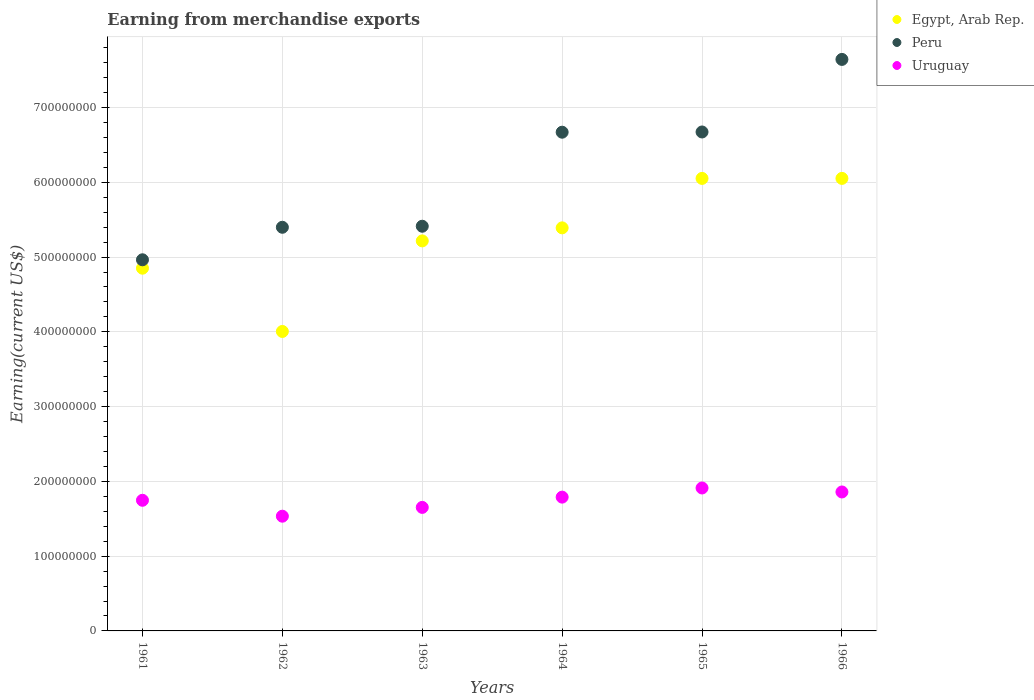What is the amount earned from merchandise exports in Peru in 1964?
Your answer should be compact. 6.67e+08. Across all years, what is the maximum amount earned from merchandise exports in Egypt, Arab Rep.?
Your response must be concise. 6.05e+08. Across all years, what is the minimum amount earned from merchandise exports in Uruguay?
Ensure brevity in your answer.  1.53e+08. In which year was the amount earned from merchandise exports in Uruguay maximum?
Keep it short and to the point. 1965. In which year was the amount earned from merchandise exports in Egypt, Arab Rep. minimum?
Offer a very short reply. 1962. What is the total amount earned from merchandise exports in Egypt, Arab Rep. in the graph?
Your answer should be compact. 3.16e+09. What is the difference between the amount earned from merchandise exports in Peru in 1961 and that in 1962?
Ensure brevity in your answer.  -4.35e+07. What is the difference between the amount earned from merchandise exports in Uruguay in 1962 and the amount earned from merchandise exports in Egypt, Arab Rep. in 1961?
Your response must be concise. -3.32e+08. What is the average amount earned from merchandise exports in Uruguay per year?
Provide a short and direct response. 1.75e+08. In the year 1962, what is the difference between the amount earned from merchandise exports in Uruguay and amount earned from merchandise exports in Peru?
Your answer should be compact. -3.86e+08. In how many years, is the amount earned from merchandise exports in Egypt, Arab Rep. greater than 540000000 US$?
Your response must be concise. 2. What is the ratio of the amount earned from merchandise exports in Egypt, Arab Rep. in 1962 to that in 1966?
Give a very brief answer. 0.66. What is the difference between the highest and the second highest amount earned from merchandise exports in Egypt, Arab Rep.?
Offer a very short reply. 2.30e+04. What is the difference between the highest and the lowest amount earned from merchandise exports in Peru?
Offer a terse response. 2.68e+08. In how many years, is the amount earned from merchandise exports in Peru greater than the average amount earned from merchandise exports in Peru taken over all years?
Give a very brief answer. 3. Is the sum of the amount earned from merchandise exports in Egypt, Arab Rep. in 1962 and 1965 greater than the maximum amount earned from merchandise exports in Peru across all years?
Ensure brevity in your answer.  Yes. Is it the case that in every year, the sum of the amount earned from merchandise exports in Peru and amount earned from merchandise exports in Egypt, Arab Rep.  is greater than the amount earned from merchandise exports in Uruguay?
Offer a terse response. Yes. Does the amount earned from merchandise exports in Peru monotonically increase over the years?
Ensure brevity in your answer.  Yes. How many dotlines are there?
Make the answer very short. 3. How many years are there in the graph?
Ensure brevity in your answer.  6. Are the values on the major ticks of Y-axis written in scientific E-notation?
Give a very brief answer. No. Does the graph contain any zero values?
Provide a short and direct response. No. Does the graph contain grids?
Make the answer very short. Yes. What is the title of the graph?
Offer a very short reply. Earning from merchandise exports. Does "Gabon" appear as one of the legend labels in the graph?
Your response must be concise. No. What is the label or title of the Y-axis?
Provide a short and direct response. Earning(current US$). What is the Earning(current US$) in Egypt, Arab Rep. in 1961?
Your response must be concise. 4.85e+08. What is the Earning(current US$) of Peru in 1961?
Provide a succinct answer. 4.96e+08. What is the Earning(current US$) in Uruguay in 1961?
Offer a terse response. 1.75e+08. What is the Earning(current US$) of Egypt, Arab Rep. in 1962?
Offer a very short reply. 4.01e+08. What is the Earning(current US$) of Peru in 1962?
Offer a terse response. 5.40e+08. What is the Earning(current US$) of Uruguay in 1962?
Provide a succinct answer. 1.53e+08. What is the Earning(current US$) in Egypt, Arab Rep. in 1963?
Provide a succinct answer. 5.22e+08. What is the Earning(current US$) of Peru in 1963?
Your answer should be compact. 5.41e+08. What is the Earning(current US$) of Uruguay in 1963?
Your answer should be very brief. 1.65e+08. What is the Earning(current US$) of Egypt, Arab Rep. in 1964?
Provide a short and direct response. 5.39e+08. What is the Earning(current US$) in Peru in 1964?
Provide a short and direct response. 6.67e+08. What is the Earning(current US$) in Uruguay in 1964?
Offer a terse response. 1.79e+08. What is the Earning(current US$) in Egypt, Arab Rep. in 1965?
Provide a succinct answer. 6.05e+08. What is the Earning(current US$) of Peru in 1965?
Ensure brevity in your answer.  6.67e+08. What is the Earning(current US$) in Uruguay in 1965?
Keep it short and to the point. 1.91e+08. What is the Earning(current US$) in Egypt, Arab Rep. in 1966?
Offer a very short reply. 6.05e+08. What is the Earning(current US$) of Peru in 1966?
Your answer should be very brief. 7.64e+08. What is the Earning(current US$) in Uruguay in 1966?
Your response must be concise. 1.86e+08. Across all years, what is the maximum Earning(current US$) of Egypt, Arab Rep.?
Keep it short and to the point. 6.05e+08. Across all years, what is the maximum Earning(current US$) of Peru?
Keep it short and to the point. 7.64e+08. Across all years, what is the maximum Earning(current US$) of Uruguay?
Your answer should be compact. 1.91e+08. Across all years, what is the minimum Earning(current US$) in Egypt, Arab Rep.?
Keep it short and to the point. 4.01e+08. Across all years, what is the minimum Earning(current US$) in Peru?
Your answer should be compact. 4.96e+08. Across all years, what is the minimum Earning(current US$) of Uruguay?
Make the answer very short. 1.53e+08. What is the total Earning(current US$) in Egypt, Arab Rep. in the graph?
Keep it short and to the point. 3.16e+09. What is the total Earning(current US$) in Peru in the graph?
Offer a very short reply. 3.68e+09. What is the total Earning(current US$) in Uruguay in the graph?
Your answer should be very brief. 1.05e+09. What is the difference between the Earning(current US$) in Egypt, Arab Rep. in 1961 and that in 1962?
Keep it short and to the point. 8.46e+07. What is the difference between the Earning(current US$) in Peru in 1961 and that in 1962?
Give a very brief answer. -4.35e+07. What is the difference between the Earning(current US$) in Uruguay in 1961 and that in 1962?
Offer a terse response. 2.13e+07. What is the difference between the Earning(current US$) in Egypt, Arab Rep. in 1961 and that in 1963?
Provide a succinct answer. -3.65e+07. What is the difference between the Earning(current US$) in Peru in 1961 and that in 1963?
Ensure brevity in your answer.  -4.49e+07. What is the difference between the Earning(current US$) of Uruguay in 1961 and that in 1963?
Provide a succinct answer. 9.51e+06. What is the difference between the Earning(current US$) in Egypt, Arab Rep. in 1961 and that in 1964?
Make the answer very short. -5.40e+07. What is the difference between the Earning(current US$) in Peru in 1961 and that in 1964?
Provide a succinct answer. -1.71e+08. What is the difference between the Earning(current US$) of Uruguay in 1961 and that in 1964?
Keep it short and to the point. -4.22e+06. What is the difference between the Earning(current US$) of Egypt, Arab Rep. in 1961 and that in 1965?
Offer a terse response. -1.20e+08. What is the difference between the Earning(current US$) of Peru in 1961 and that in 1965?
Make the answer very short. -1.71e+08. What is the difference between the Earning(current US$) in Uruguay in 1961 and that in 1965?
Provide a short and direct response. -1.64e+07. What is the difference between the Earning(current US$) in Egypt, Arab Rep. in 1961 and that in 1966?
Give a very brief answer. -1.20e+08. What is the difference between the Earning(current US$) of Peru in 1961 and that in 1966?
Your response must be concise. -2.68e+08. What is the difference between the Earning(current US$) in Uruguay in 1961 and that in 1966?
Give a very brief answer. -1.11e+07. What is the difference between the Earning(current US$) in Egypt, Arab Rep. in 1962 and that in 1963?
Provide a short and direct response. -1.21e+08. What is the difference between the Earning(current US$) of Peru in 1962 and that in 1963?
Your answer should be very brief. -1.38e+06. What is the difference between the Earning(current US$) in Uruguay in 1962 and that in 1963?
Give a very brief answer. -1.18e+07. What is the difference between the Earning(current US$) in Egypt, Arab Rep. in 1962 and that in 1964?
Make the answer very short. -1.39e+08. What is the difference between the Earning(current US$) in Peru in 1962 and that in 1964?
Provide a short and direct response. -1.27e+08. What is the difference between the Earning(current US$) in Uruguay in 1962 and that in 1964?
Offer a very short reply. -2.55e+07. What is the difference between the Earning(current US$) of Egypt, Arab Rep. in 1962 and that in 1965?
Your response must be concise. -2.05e+08. What is the difference between the Earning(current US$) in Peru in 1962 and that in 1965?
Your response must be concise. -1.27e+08. What is the difference between the Earning(current US$) in Uruguay in 1962 and that in 1965?
Your response must be concise. -3.77e+07. What is the difference between the Earning(current US$) in Egypt, Arab Rep. in 1962 and that in 1966?
Your response must be concise. -2.05e+08. What is the difference between the Earning(current US$) in Peru in 1962 and that in 1966?
Provide a short and direct response. -2.25e+08. What is the difference between the Earning(current US$) of Uruguay in 1962 and that in 1966?
Keep it short and to the point. -3.24e+07. What is the difference between the Earning(current US$) in Egypt, Arab Rep. in 1963 and that in 1964?
Your answer should be very brief. -1.74e+07. What is the difference between the Earning(current US$) in Peru in 1963 and that in 1964?
Provide a short and direct response. -1.26e+08. What is the difference between the Earning(current US$) of Uruguay in 1963 and that in 1964?
Ensure brevity in your answer.  -1.37e+07. What is the difference between the Earning(current US$) of Egypt, Arab Rep. in 1963 and that in 1965?
Offer a terse response. -8.36e+07. What is the difference between the Earning(current US$) of Peru in 1963 and that in 1965?
Your answer should be compact. -1.26e+08. What is the difference between the Earning(current US$) in Uruguay in 1963 and that in 1965?
Keep it short and to the point. -2.60e+07. What is the difference between the Earning(current US$) of Egypt, Arab Rep. in 1963 and that in 1966?
Keep it short and to the point. -8.36e+07. What is the difference between the Earning(current US$) of Peru in 1963 and that in 1966?
Provide a succinct answer. -2.23e+08. What is the difference between the Earning(current US$) in Uruguay in 1963 and that in 1966?
Offer a terse response. -2.06e+07. What is the difference between the Earning(current US$) of Egypt, Arab Rep. in 1964 and that in 1965?
Ensure brevity in your answer.  -6.61e+07. What is the difference between the Earning(current US$) of Peru in 1964 and that in 1965?
Your answer should be very brief. -2.99e+05. What is the difference between the Earning(current US$) in Uruguay in 1964 and that in 1965?
Provide a short and direct response. -1.22e+07. What is the difference between the Earning(current US$) of Egypt, Arab Rep. in 1964 and that in 1966?
Make the answer very short. -6.61e+07. What is the difference between the Earning(current US$) in Peru in 1964 and that in 1966?
Ensure brevity in your answer.  -9.74e+07. What is the difference between the Earning(current US$) of Uruguay in 1964 and that in 1966?
Ensure brevity in your answer.  -6.90e+06. What is the difference between the Earning(current US$) in Egypt, Arab Rep. in 1965 and that in 1966?
Your answer should be very brief. -2.30e+04. What is the difference between the Earning(current US$) of Peru in 1965 and that in 1966?
Your response must be concise. -9.71e+07. What is the difference between the Earning(current US$) in Uruguay in 1965 and that in 1966?
Your response must be concise. 5.33e+06. What is the difference between the Earning(current US$) in Egypt, Arab Rep. in 1961 and the Earning(current US$) in Peru in 1962?
Offer a very short reply. -5.47e+07. What is the difference between the Earning(current US$) in Egypt, Arab Rep. in 1961 and the Earning(current US$) in Uruguay in 1962?
Offer a terse response. 3.32e+08. What is the difference between the Earning(current US$) in Peru in 1961 and the Earning(current US$) in Uruguay in 1962?
Your response must be concise. 3.43e+08. What is the difference between the Earning(current US$) of Egypt, Arab Rep. in 1961 and the Earning(current US$) of Peru in 1963?
Make the answer very short. -5.61e+07. What is the difference between the Earning(current US$) in Egypt, Arab Rep. in 1961 and the Earning(current US$) in Uruguay in 1963?
Your answer should be compact. 3.20e+08. What is the difference between the Earning(current US$) in Peru in 1961 and the Earning(current US$) in Uruguay in 1963?
Keep it short and to the point. 3.31e+08. What is the difference between the Earning(current US$) in Egypt, Arab Rep. in 1961 and the Earning(current US$) in Peru in 1964?
Offer a very short reply. -1.82e+08. What is the difference between the Earning(current US$) of Egypt, Arab Rep. in 1961 and the Earning(current US$) of Uruguay in 1964?
Keep it short and to the point. 3.06e+08. What is the difference between the Earning(current US$) in Peru in 1961 and the Earning(current US$) in Uruguay in 1964?
Offer a terse response. 3.17e+08. What is the difference between the Earning(current US$) of Egypt, Arab Rep. in 1961 and the Earning(current US$) of Peru in 1965?
Offer a very short reply. -1.82e+08. What is the difference between the Earning(current US$) in Egypt, Arab Rep. in 1961 and the Earning(current US$) in Uruguay in 1965?
Offer a very short reply. 2.94e+08. What is the difference between the Earning(current US$) of Peru in 1961 and the Earning(current US$) of Uruguay in 1965?
Provide a succinct answer. 3.05e+08. What is the difference between the Earning(current US$) of Egypt, Arab Rep. in 1961 and the Earning(current US$) of Peru in 1966?
Your answer should be compact. -2.79e+08. What is the difference between the Earning(current US$) of Egypt, Arab Rep. in 1961 and the Earning(current US$) of Uruguay in 1966?
Keep it short and to the point. 2.99e+08. What is the difference between the Earning(current US$) of Peru in 1961 and the Earning(current US$) of Uruguay in 1966?
Offer a very short reply. 3.11e+08. What is the difference between the Earning(current US$) in Egypt, Arab Rep. in 1962 and the Earning(current US$) in Peru in 1963?
Make the answer very short. -1.41e+08. What is the difference between the Earning(current US$) of Egypt, Arab Rep. in 1962 and the Earning(current US$) of Uruguay in 1963?
Give a very brief answer. 2.35e+08. What is the difference between the Earning(current US$) in Peru in 1962 and the Earning(current US$) in Uruguay in 1963?
Offer a terse response. 3.75e+08. What is the difference between the Earning(current US$) in Egypt, Arab Rep. in 1962 and the Earning(current US$) in Peru in 1964?
Your answer should be compact. -2.66e+08. What is the difference between the Earning(current US$) in Egypt, Arab Rep. in 1962 and the Earning(current US$) in Uruguay in 1964?
Your answer should be very brief. 2.22e+08. What is the difference between the Earning(current US$) of Peru in 1962 and the Earning(current US$) of Uruguay in 1964?
Provide a succinct answer. 3.61e+08. What is the difference between the Earning(current US$) in Egypt, Arab Rep. in 1962 and the Earning(current US$) in Peru in 1965?
Offer a terse response. -2.67e+08. What is the difference between the Earning(current US$) in Egypt, Arab Rep. in 1962 and the Earning(current US$) in Uruguay in 1965?
Keep it short and to the point. 2.09e+08. What is the difference between the Earning(current US$) in Peru in 1962 and the Earning(current US$) in Uruguay in 1965?
Give a very brief answer. 3.49e+08. What is the difference between the Earning(current US$) of Egypt, Arab Rep. in 1962 and the Earning(current US$) of Peru in 1966?
Ensure brevity in your answer.  -3.64e+08. What is the difference between the Earning(current US$) in Egypt, Arab Rep. in 1962 and the Earning(current US$) in Uruguay in 1966?
Keep it short and to the point. 2.15e+08. What is the difference between the Earning(current US$) in Peru in 1962 and the Earning(current US$) in Uruguay in 1966?
Keep it short and to the point. 3.54e+08. What is the difference between the Earning(current US$) of Egypt, Arab Rep. in 1963 and the Earning(current US$) of Peru in 1964?
Keep it short and to the point. -1.45e+08. What is the difference between the Earning(current US$) in Egypt, Arab Rep. in 1963 and the Earning(current US$) in Uruguay in 1964?
Your answer should be very brief. 3.43e+08. What is the difference between the Earning(current US$) of Peru in 1963 and the Earning(current US$) of Uruguay in 1964?
Keep it short and to the point. 3.62e+08. What is the difference between the Earning(current US$) in Egypt, Arab Rep. in 1963 and the Earning(current US$) in Peru in 1965?
Your response must be concise. -1.46e+08. What is the difference between the Earning(current US$) of Egypt, Arab Rep. in 1963 and the Earning(current US$) of Uruguay in 1965?
Your answer should be compact. 3.30e+08. What is the difference between the Earning(current US$) of Peru in 1963 and the Earning(current US$) of Uruguay in 1965?
Make the answer very short. 3.50e+08. What is the difference between the Earning(current US$) of Egypt, Arab Rep. in 1963 and the Earning(current US$) of Peru in 1966?
Your answer should be compact. -2.43e+08. What is the difference between the Earning(current US$) in Egypt, Arab Rep. in 1963 and the Earning(current US$) in Uruguay in 1966?
Provide a short and direct response. 3.36e+08. What is the difference between the Earning(current US$) of Peru in 1963 and the Earning(current US$) of Uruguay in 1966?
Provide a short and direct response. 3.55e+08. What is the difference between the Earning(current US$) in Egypt, Arab Rep. in 1964 and the Earning(current US$) in Peru in 1965?
Offer a terse response. -1.28e+08. What is the difference between the Earning(current US$) of Egypt, Arab Rep. in 1964 and the Earning(current US$) of Uruguay in 1965?
Make the answer very short. 3.48e+08. What is the difference between the Earning(current US$) of Peru in 1964 and the Earning(current US$) of Uruguay in 1965?
Your answer should be compact. 4.76e+08. What is the difference between the Earning(current US$) of Egypt, Arab Rep. in 1964 and the Earning(current US$) of Peru in 1966?
Offer a very short reply. -2.25e+08. What is the difference between the Earning(current US$) of Egypt, Arab Rep. in 1964 and the Earning(current US$) of Uruguay in 1966?
Your response must be concise. 3.53e+08. What is the difference between the Earning(current US$) of Peru in 1964 and the Earning(current US$) of Uruguay in 1966?
Your answer should be compact. 4.81e+08. What is the difference between the Earning(current US$) of Egypt, Arab Rep. in 1965 and the Earning(current US$) of Peru in 1966?
Make the answer very short. -1.59e+08. What is the difference between the Earning(current US$) in Egypt, Arab Rep. in 1965 and the Earning(current US$) in Uruguay in 1966?
Provide a short and direct response. 4.19e+08. What is the difference between the Earning(current US$) of Peru in 1965 and the Earning(current US$) of Uruguay in 1966?
Give a very brief answer. 4.81e+08. What is the average Earning(current US$) of Egypt, Arab Rep. per year?
Provide a short and direct response. 5.26e+08. What is the average Earning(current US$) in Peru per year?
Provide a succinct answer. 6.13e+08. What is the average Earning(current US$) in Uruguay per year?
Ensure brevity in your answer.  1.75e+08. In the year 1961, what is the difference between the Earning(current US$) of Egypt, Arab Rep. and Earning(current US$) of Peru?
Your answer should be very brief. -1.13e+07. In the year 1961, what is the difference between the Earning(current US$) of Egypt, Arab Rep. and Earning(current US$) of Uruguay?
Your response must be concise. 3.10e+08. In the year 1961, what is the difference between the Earning(current US$) of Peru and Earning(current US$) of Uruguay?
Make the answer very short. 3.22e+08. In the year 1962, what is the difference between the Earning(current US$) in Egypt, Arab Rep. and Earning(current US$) in Peru?
Your response must be concise. -1.39e+08. In the year 1962, what is the difference between the Earning(current US$) in Egypt, Arab Rep. and Earning(current US$) in Uruguay?
Your answer should be very brief. 2.47e+08. In the year 1962, what is the difference between the Earning(current US$) in Peru and Earning(current US$) in Uruguay?
Your answer should be very brief. 3.86e+08. In the year 1963, what is the difference between the Earning(current US$) in Egypt, Arab Rep. and Earning(current US$) in Peru?
Keep it short and to the point. -1.96e+07. In the year 1963, what is the difference between the Earning(current US$) in Egypt, Arab Rep. and Earning(current US$) in Uruguay?
Your answer should be compact. 3.56e+08. In the year 1963, what is the difference between the Earning(current US$) in Peru and Earning(current US$) in Uruguay?
Provide a succinct answer. 3.76e+08. In the year 1964, what is the difference between the Earning(current US$) of Egypt, Arab Rep. and Earning(current US$) of Peru?
Provide a short and direct response. -1.28e+08. In the year 1964, what is the difference between the Earning(current US$) of Egypt, Arab Rep. and Earning(current US$) of Uruguay?
Offer a very short reply. 3.60e+08. In the year 1964, what is the difference between the Earning(current US$) in Peru and Earning(current US$) in Uruguay?
Give a very brief answer. 4.88e+08. In the year 1965, what is the difference between the Earning(current US$) in Egypt, Arab Rep. and Earning(current US$) in Peru?
Offer a very short reply. -6.21e+07. In the year 1965, what is the difference between the Earning(current US$) in Egypt, Arab Rep. and Earning(current US$) in Uruguay?
Ensure brevity in your answer.  4.14e+08. In the year 1965, what is the difference between the Earning(current US$) of Peru and Earning(current US$) of Uruguay?
Offer a terse response. 4.76e+08. In the year 1966, what is the difference between the Earning(current US$) in Egypt, Arab Rep. and Earning(current US$) in Peru?
Provide a short and direct response. -1.59e+08. In the year 1966, what is the difference between the Earning(current US$) of Egypt, Arab Rep. and Earning(current US$) of Uruguay?
Provide a short and direct response. 4.19e+08. In the year 1966, what is the difference between the Earning(current US$) of Peru and Earning(current US$) of Uruguay?
Provide a short and direct response. 5.79e+08. What is the ratio of the Earning(current US$) in Egypt, Arab Rep. in 1961 to that in 1962?
Your response must be concise. 1.21. What is the ratio of the Earning(current US$) in Peru in 1961 to that in 1962?
Ensure brevity in your answer.  0.92. What is the ratio of the Earning(current US$) of Uruguay in 1961 to that in 1962?
Offer a very short reply. 1.14. What is the ratio of the Earning(current US$) in Egypt, Arab Rep. in 1961 to that in 1963?
Keep it short and to the point. 0.93. What is the ratio of the Earning(current US$) of Peru in 1961 to that in 1963?
Your answer should be very brief. 0.92. What is the ratio of the Earning(current US$) in Uruguay in 1961 to that in 1963?
Your answer should be very brief. 1.06. What is the ratio of the Earning(current US$) of Egypt, Arab Rep. in 1961 to that in 1964?
Your answer should be compact. 0.9. What is the ratio of the Earning(current US$) of Peru in 1961 to that in 1964?
Offer a very short reply. 0.74. What is the ratio of the Earning(current US$) of Uruguay in 1961 to that in 1964?
Provide a succinct answer. 0.98. What is the ratio of the Earning(current US$) of Egypt, Arab Rep. in 1961 to that in 1965?
Make the answer very short. 0.8. What is the ratio of the Earning(current US$) in Peru in 1961 to that in 1965?
Your answer should be very brief. 0.74. What is the ratio of the Earning(current US$) in Uruguay in 1961 to that in 1965?
Offer a terse response. 0.91. What is the ratio of the Earning(current US$) of Egypt, Arab Rep. in 1961 to that in 1966?
Make the answer very short. 0.8. What is the ratio of the Earning(current US$) in Peru in 1961 to that in 1966?
Provide a succinct answer. 0.65. What is the ratio of the Earning(current US$) of Uruguay in 1961 to that in 1966?
Make the answer very short. 0.94. What is the ratio of the Earning(current US$) in Egypt, Arab Rep. in 1962 to that in 1963?
Offer a terse response. 0.77. What is the ratio of the Earning(current US$) of Peru in 1962 to that in 1963?
Provide a short and direct response. 1. What is the ratio of the Earning(current US$) in Uruguay in 1962 to that in 1963?
Make the answer very short. 0.93. What is the ratio of the Earning(current US$) in Egypt, Arab Rep. in 1962 to that in 1964?
Ensure brevity in your answer.  0.74. What is the ratio of the Earning(current US$) of Peru in 1962 to that in 1964?
Provide a short and direct response. 0.81. What is the ratio of the Earning(current US$) in Uruguay in 1962 to that in 1964?
Keep it short and to the point. 0.86. What is the ratio of the Earning(current US$) in Egypt, Arab Rep. in 1962 to that in 1965?
Ensure brevity in your answer.  0.66. What is the ratio of the Earning(current US$) of Peru in 1962 to that in 1965?
Your response must be concise. 0.81. What is the ratio of the Earning(current US$) in Uruguay in 1962 to that in 1965?
Provide a succinct answer. 0.8. What is the ratio of the Earning(current US$) of Egypt, Arab Rep. in 1962 to that in 1966?
Offer a terse response. 0.66. What is the ratio of the Earning(current US$) in Peru in 1962 to that in 1966?
Your answer should be compact. 0.71. What is the ratio of the Earning(current US$) of Uruguay in 1962 to that in 1966?
Your response must be concise. 0.83. What is the ratio of the Earning(current US$) in Peru in 1963 to that in 1964?
Keep it short and to the point. 0.81. What is the ratio of the Earning(current US$) in Uruguay in 1963 to that in 1964?
Ensure brevity in your answer.  0.92. What is the ratio of the Earning(current US$) in Egypt, Arab Rep. in 1963 to that in 1965?
Provide a short and direct response. 0.86. What is the ratio of the Earning(current US$) of Peru in 1963 to that in 1965?
Provide a short and direct response. 0.81. What is the ratio of the Earning(current US$) in Uruguay in 1963 to that in 1965?
Provide a succinct answer. 0.86. What is the ratio of the Earning(current US$) of Egypt, Arab Rep. in 1963 to that in 1966?
Make the answer very short. 0.86. What is the ratio of the Earning(current US$) in Peru in 1963 to that in 1966?
Make the answer very short. 0.71. What is the ratio of the Earning(current US$) of Uruguay in 1963 to that in 1966?
Make the answer very short. 0.89. What is the ratio of the Earning(current US$) of Egypt, Arab Rep. in 1964 to that in 1965?
Offer a very short reply. 0.89. What is the ratio of the Earning(current US$) of Peru in 1964 to that in 1965?
Offer a very short reply. 1. What is the ratio of the Earning(current US$) in Uruguay in 1964 to that in 1965?
Keep it short and to the point. 0.94. What is the ratio of the Earning(current US$) in Egypt, Arab Rep. in 1964 to that in 1966?
Give a very brief answer. 0.89. What is the ratio of the Earning(current US$) of Peru in 1964 to that in 1966?
Provide a succinct answer. 0.87. What is the ratio of the Earning(current US$) of Uruguay in 1964 to that in 1966?
Provide a succinct answer. 0.96. What is the ratio of the Earning(current US$) of Egypt, Arab Rep. in 1965 to that in 1966?
Your answer should be compact. 1. What is the ratio of the Earning(current US$) of Peru in 1965 to that in 1966?
Your answer should be compact. 0.87. What is the ratio of the Earning(current US$) of Uruguay in 1965 to that in 1966?
Your response must be concise. 1.03. What is the difference between the highest and the second highest Earning(current US$) in Egypt, Arab Rep.?
Offer a very short reply. 2.30e+04. What is the difference between the highest and the second highest Earning(current US$) in Peru?
Offer a terse response. 9.71e+07. What is the difference between the highest and the second highest Earning(current US$) of Uruguay?
Your answer should be very brief. 5.33e+06. What is the difference between the highest and the lowest Earning(current US$) of Egypt, Arab Rep.?
Give a very brief answer. 2.05e+08. What is the difference between the highest and the lowest Earning(current US$) in Peru?
Offer a terse response. 2.68e+08. What is the difference between the highest and the lowest Earning(current US$) in Uruguay?
Keep it short and to the point. 3.77e+07. 